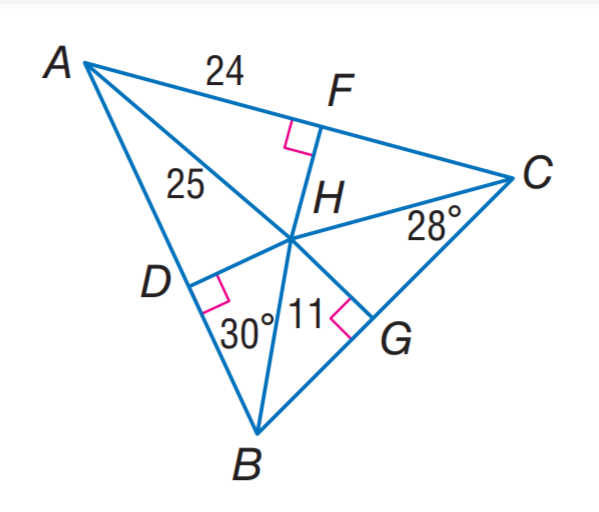Answer the mathemtical geometry problem and directly provide the correct option letter.
Question: H is the incenter of \triangle A B C. Find m \angle D H G.
Choices: A: 60 B: 100 C: 120 D: 150 C 